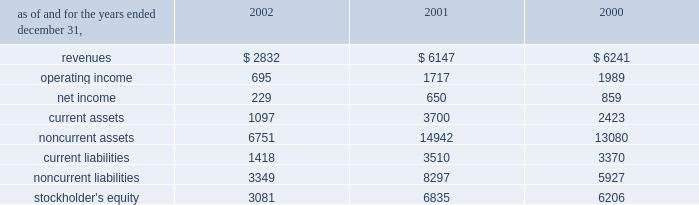Affiliated company .
The loss recorded on the sale was approximately $ 14 million and is recorded as a loss on sale of assets and asset impairment expenses in the accompanying consolidated statements of operations .
In the second quarter of 2002 , the company recorded an impairment charge of approximately $ 40 million , after income taxes , on an equity method investment in a telecommunications company in latin america held by edc .
The impairment charge resulted from sustained poor operating performance coupled with recent funding problems at the invested company .
During 2001 , the company lost operational control of central electricity supply corporation ( 2018 2018cesco 2019 2019 ) , a distribution company located in the state of orissa , india .
Cesco is accounted for as a cost method investment .
In may 2000 , the company completed the acquisition of 100% ( 100 % ) of tractebel power ltd ( 2018 2018tpl 2019 2019 ) for approximately $ 67 million and assumed liabilities of approximately $ 200 million .
Tpl owned 46% ( 46 % ) of nigen .
The company also acquired an additional 6% ( 6 % ) interest in nigen from minority stockholders during the year ended december 31 , 2000 through the issuance of approximately 99000 common shares of aes stock valued at approximately $ 4.9 million .
With the completion of these transactions , the company owns approximately 98% ( 98 % ) of nigen 2019s common stock and began consolidating its financial results beginning may 12 , 2000 .
Approximately $ 100 million of the purchase price was allocated to excess of costs over net assets acquired and was amortized through january 1 , 2002 at which time the company adopted sfas no .
142 and ceased amortization of goodwill .
In august 2000 , a subsidiary of the company acquired a 49% ( 49 % ) interest in songas limited ( 2018 2018songas 2019 2019 ) for approximately $ 40 million .
The company acquired an additional 16.79% ( 16.79 % ) of songas for approximately $ 12.5 million , and the company began consolidating this entity in 2002 .
Songas owns the songo songo gas-to-electricity project in tanzania .
In december 2002 , the company signed a sales purchase agreement to sell songas .
The sale is expected to close in early 2003 .
See note 4 for further discussion of the transaction .
The table presents summarized comparative financial information ( in millions ) for the company 2019s investments in 50% ( 50 % ) or less owned investments accounted for using the equity method. .
In 2002 , 2001 and 2000 , the results of operations and the financial position of cemig were negatively impacted by the devaluation of the brazilian real and the impairment charge recorded in 2002 .
The brazilian real devalued 32% ( 32 % ) , 19% ( 19 % ) and 8% ( 8 % ) for the years ended december 31 , 2002 , 2001 and 2000 , respectively .
The company recorded $ 83 million , $ 210 million , and $ 64 million of pre-tax non-cash foreign currency transaction losses on its investments in brazilian equity method affiliates during 2002 , 2001 and 2000 , respectively. .
What is the implied value of nigen based on the 2000 acquisition? 
Computations: (4.9 / 6%)
Answer: 81.66667. 